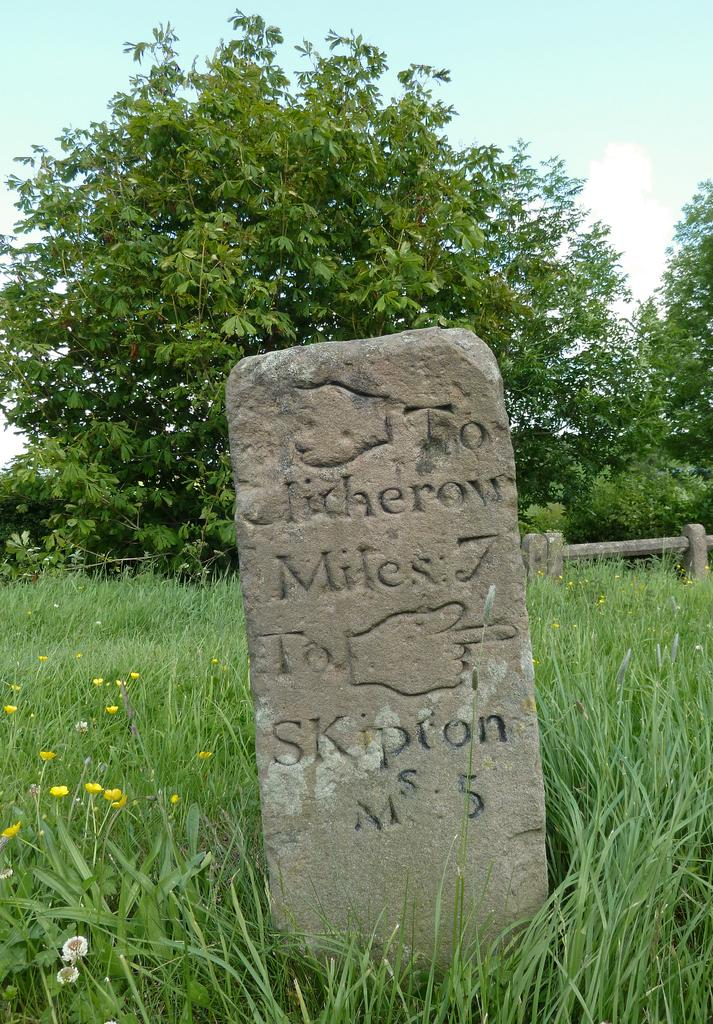What is the main object in the image? There is a pole in the image. What is written or displayed on the pole? There are texts and a symbol on the pole. What is the location of the pole in relation to the surrounding environment? The pole is near grass and plants. What type of plants are present near the pole? The plants have flowers. What can be seen in the background of the image? There are trees and clouds in the sky. What is the color of the sky in the image? The sky is blue. Who is the manager of the bees buzzing around the pole in the image? There are no bees present in the image, so there is no manager for them. 